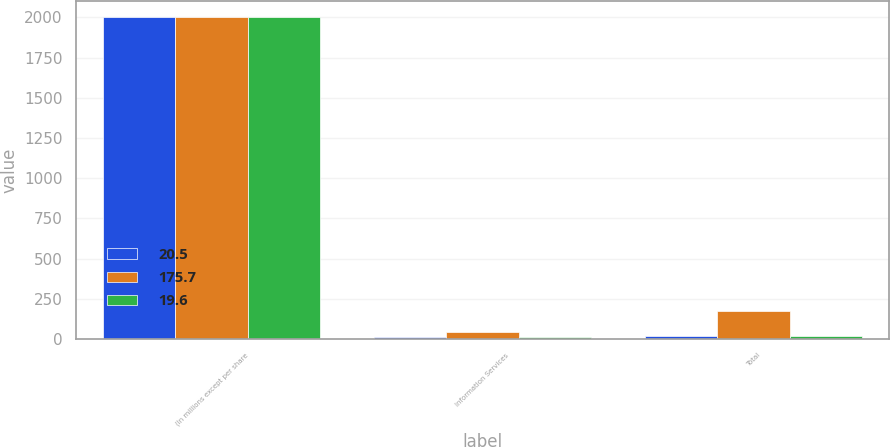Convert chart to OTSL. <chart><loc_0><loc_0><loc_500><loc_500><stacked_bar_chart><ecel><fcel>(In millions except per share<fcel>Information Services<fcel>Total<nl><fcel>20.5<fcel>2003<fcel>12.7<fcel>19.6<nl><fcel>175.7<fcel>2002<fcel>43.4<fcel>175.7<nl><fcel>19.6<fcel>2001<fcel>13.2<fcel>20.5<nl></chart> 